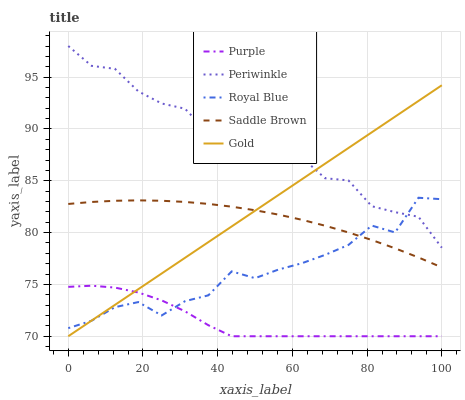Does Royal Blue have the minimum area under the curve?
Answer yes or no. No. Does Royal Blue have the maximum area under the curve?
Answer yes or no. No. Is Royal Blue the smoothest?
Answer yes or no. No. Is Royal Blue the roughest?
Answer yes or no. No. Does Royal Blue have the lowest value?
Answer yes or no. No. Does Royal Blue have the highest value?
Answer yes or no. No. Is Purple less than Periwinkle?
Answer yes or no. Yes. Is Periwinkle greater than Saddle Brown?
Answer yes or no. Yes. Does Purple intersect Periwinkle?
Answer yes or no. No. 